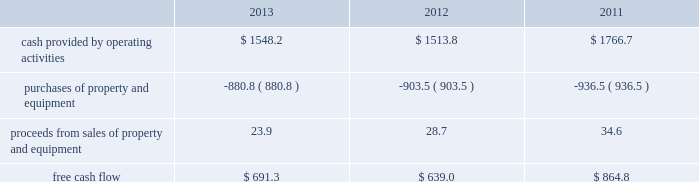Constitutes an event of default under our other debt instruments , including our senior notes , and , therefore , our senior notes would also be subject to acceleration of maturity .
If such acceleration were to occur , we would not have sufficient liquidity available to repay the indebtedness .
We would likely have to seek an amendment under our credit facilities for relief from the financial covenants or repay the debt with proceeds from the issuance of new debt or equity , or asset sales , if necessary .
We may be unable to amend our credit facilities or raise sufficient capital to repay such obligations in the event the maturities are accelerated .
Financial assurance we must provide financial assurance to governmental agencies and a variety of other entities under applicable environmental regulations relating to our landfill operations for capping , closure and post-closure costs , and related to our performance under certain collection , landfill and transfer station contracts .
We satisfy these financial assurance requirements by providing surety bonds , letters of credit , or insurance policies ( the financial assurance instruments ) , or trust deposits , which are included in restricted cash and marketable securities and other assets in our consolidated balance sheets .
The amount of the financial assurance requirements for capping , closure and post-closure costs is determined by applicable state environmental regulations .
The financial assurance requirements for capping , closure and post-closure costs may be associated with a portion of the landfill or the entire landfill .
Generally , states require a third-party engineering specialist to determine the estimated capping , closure and post-closure costs that are used to determine the required amount of financial assurance for a landfill .
The amount of financial assurance required can , and generally will , differ from the obligation determined and recorded under u.s .
Gaap .
The amount of the financial assurance requirements related to contract performance varies by contract .
Additionally , we must provide financial assurance for our insurance program and collateral for certain performance obligations .
We do not expect a material increase in financial assurance requirements during 2014 , although the mix of financial assurance instruments may change .
These financial instruments are issued in the normal course of business and are not considered indebtedness .
Because we currently have no liability for the financial assurance instruments , they are not reflected in our consolidated balance sheets ; however , we record capping , closure and post-closure liabilities and self-insurance liabilities as they are incurred .
The underlying obligations of the financial assurance instruments , in excess of those already reflected in our consolidated balance sheets , would be recorded if it is probable that we would be unable to fulfill our related obligations .
We do not expect this to occur .
Off-balance sheet arrangements we have no off-balance sheet debt or similar obligations , other than financial assurance instruments and operating leases , that are not classified as debt .
We do not guarantee any third-party debt .
Free cash flow we define free cash flow , which is not a measure determined in accordance with u.s .
Gaap , as cash provided by operating activities less purchases of property and equipment , plus proceeds from sales of property and equipment as presented in our consolidated statements of cash flows .
Our free cash flow for the years ended december 31 , 2013 , 2012 and 2011 is calculated as follows ( in millions of dollars ) : .

In 2013 what was the ratio of the cash provided by operating activities to the amount spent on purchases of property and the equipment? 
Rationale: for every $ 1.76 of cash from operations $ 1 was spent on the purchase of purchases of property and equipment
Computations: (1548.2 / 880.8)
Answer: 1.75772. 